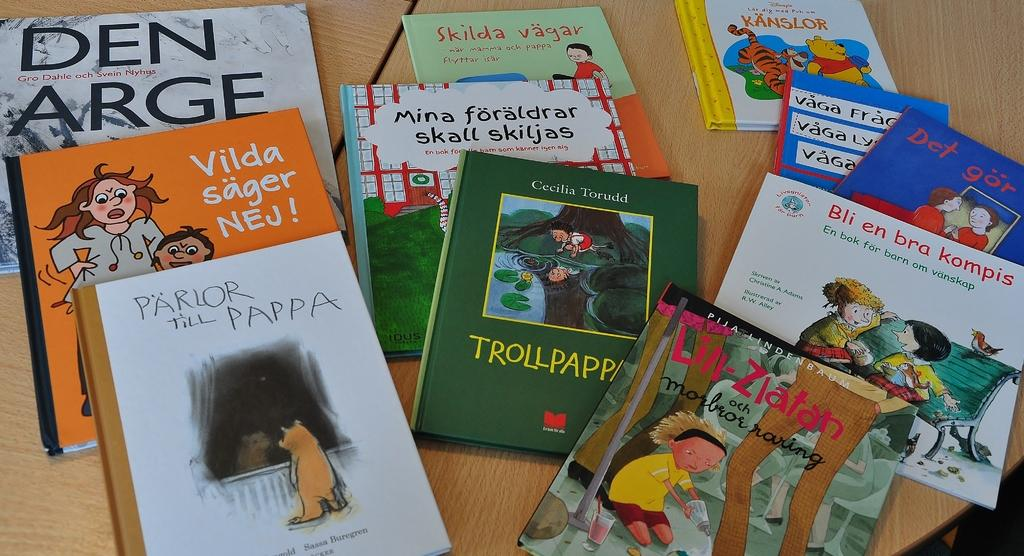<image>
Write a terse but informative summary of the picture. Several books sitting on a table with titles such as PARLOR THE PAPPA. 